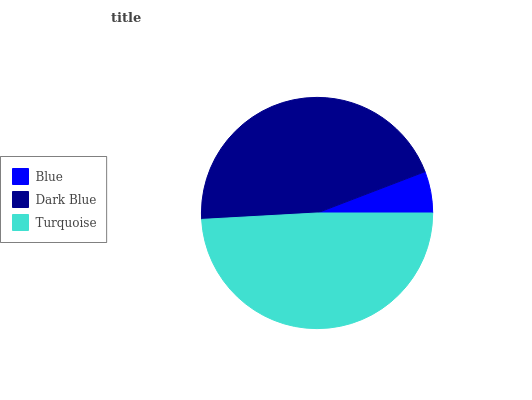Is Blue the minimum?
Answer yes or no. Yes. Is Turquoise the maximum?
Answer yes or no. Yes. Is Dark Blue the minimum?
Answer yes or no. No. Is Dark Blue the maximum?
Answer yes or no. No. Is Dark Blue greater than Blue?
Answer yes or no. Yes. Is Blue less than Dark Blue?
Answer yes or no. Yes. Is Blue greater than Dark Blue?
Answer yes or no. No. Is Dark Blue less than Blue?
Answer yes or no. No. Is Dark Blue the high median?
Answer yes or no. Yes. Is Dark Blue the low median?
Answer yes or no. Yes. Is Turquoise the high median?
Answer yes or no. No. Is Turquoise the low median?
Answer yes or no. No. 